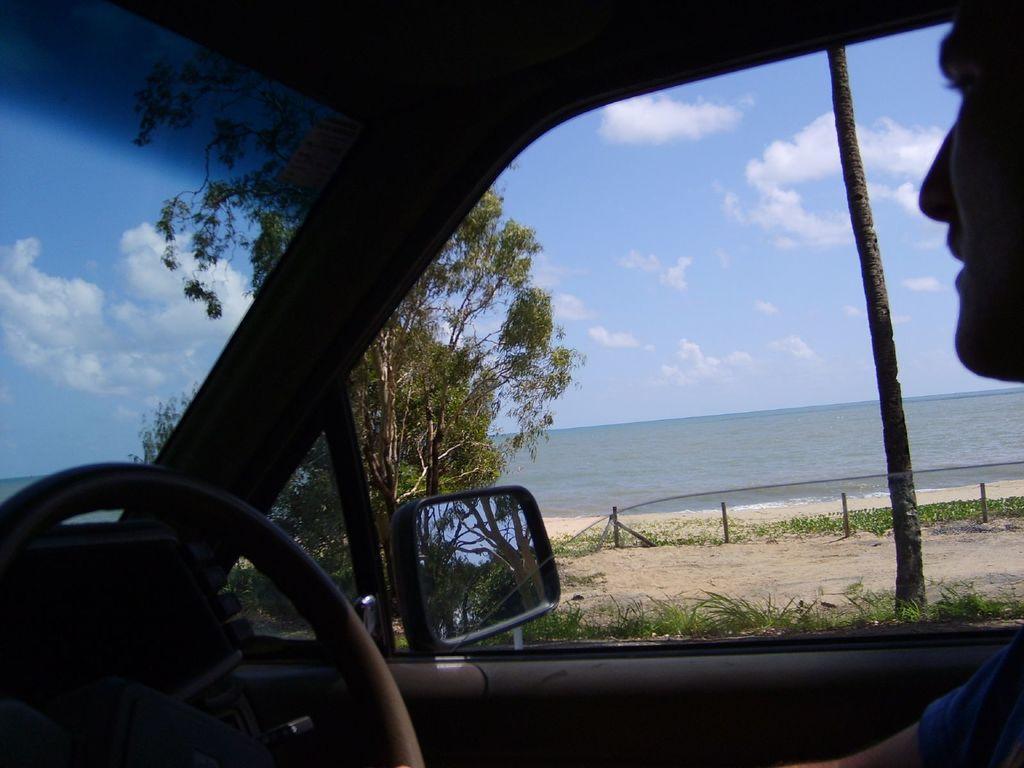In one or two sentences, can you explain what this image depicts? The picture is captured inside a car,there is a man sitting in front of the steering. Outside the car there are trees,plants and behind them there is a sea. 